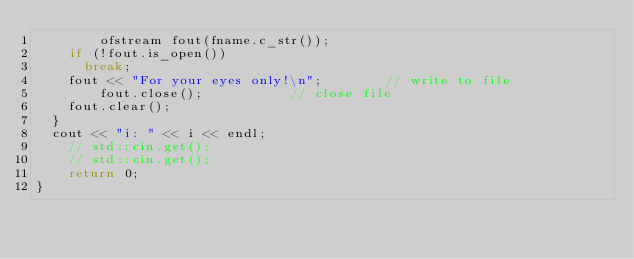Convert code to text. <code><loc_0><loc_0><loc_500><loc_500><_C++_>        ofstream fout(fname.c_str());
		if (!fout.is_open())
			break;
		fout << "For your eyes only!\n";        // write to file
        fout.close();           // close file
		fout.clear();
	}
	cout << "i: " << i << endl;
    // std::cin.get();
    // std::cin.get();
    return 0; 
}
</code> 